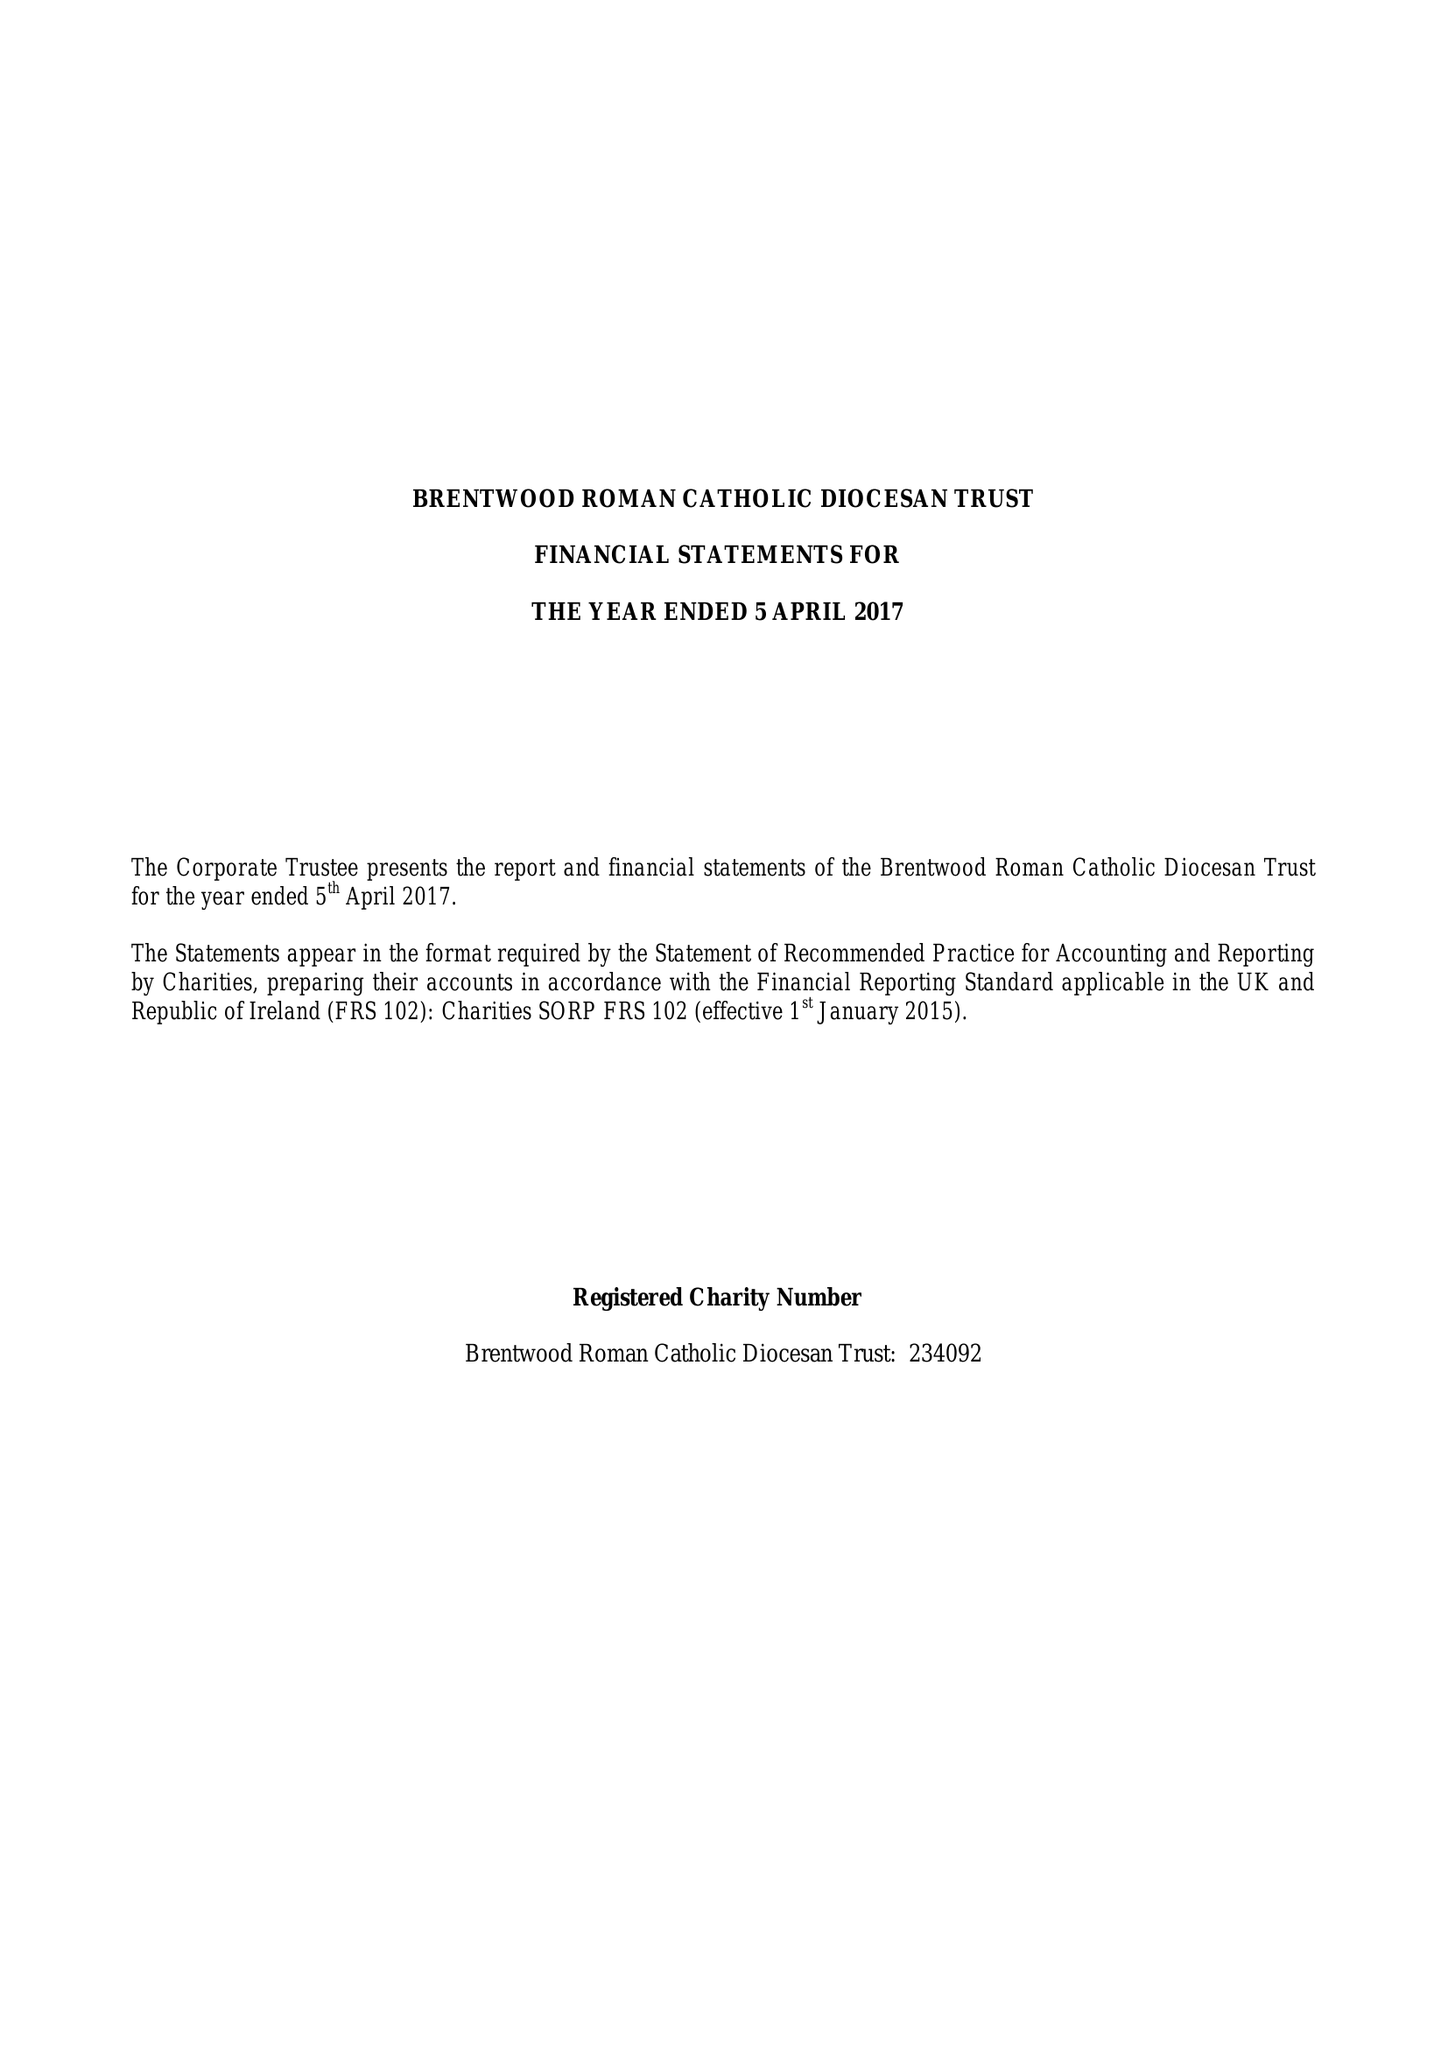What is the value for the address__street_line?
Answer the question using a single word or phrase. INGRAVE ROAD 